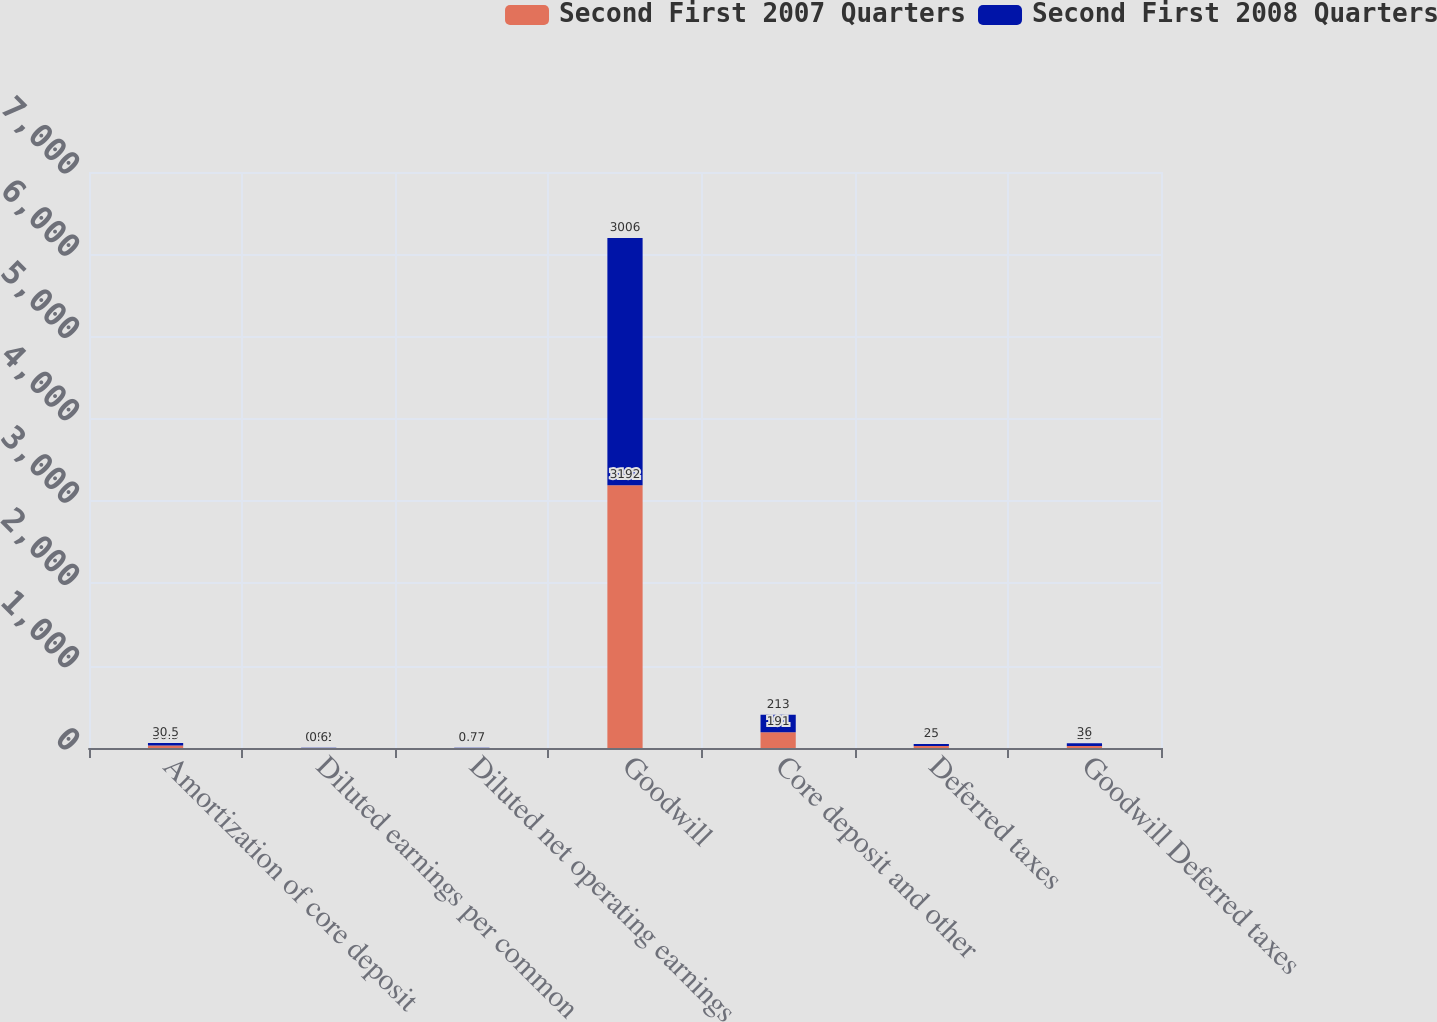Convert chart. <chart><loc_0><loc_0><loc_500><loc_500><stacked_bar_chart><ecel><fcel>Amortization of core deposit<fcel>Diluted earnings per common<fcel>Diluted net operating earnings<fcel>Goodwill<fcel>Core deposit and other<fcel>Deferred taxes<fcel>Goodwill Deferred taxes<nl><fcel>Second First 2007 Quarters<fcel>30.5<fcel>0.92<fcel>1<fcel>3192<fcel>191<fcel>25<fcel>23<nl><fcel>Second First 2008 Quarters<fcel>30.5<fcel>0.6<fcel>0.77<fcel>3006<fcel>213<fcel>25<fcel>36<nl></chart> 